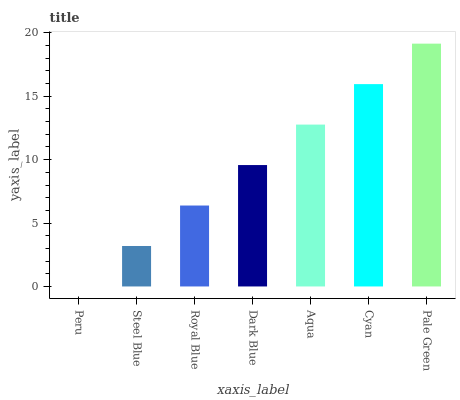Is Steel Blue the minimum?
Answer yes or no. No. Is Steel Blue the maximum?
Answer yes or no. No. Is Steel Blue greater than Peru?
Answer yes or no. Yes. Is Peru less than Steel Blue?
Answer yes or no. Yes. Is Peru greater than Steel Blue?
Answer yes or no. No. Is Steel Blue less than Peru?
Answer yes or no. No. Is Dark Blue the high median?
Answer yes or no. Yes. Is Dark Blue the low median?
Answer yes or no. Yes. Is Aqua the high median?
Answer yes or no. No. Is Peru the low median?
Answer yes or no. No. 